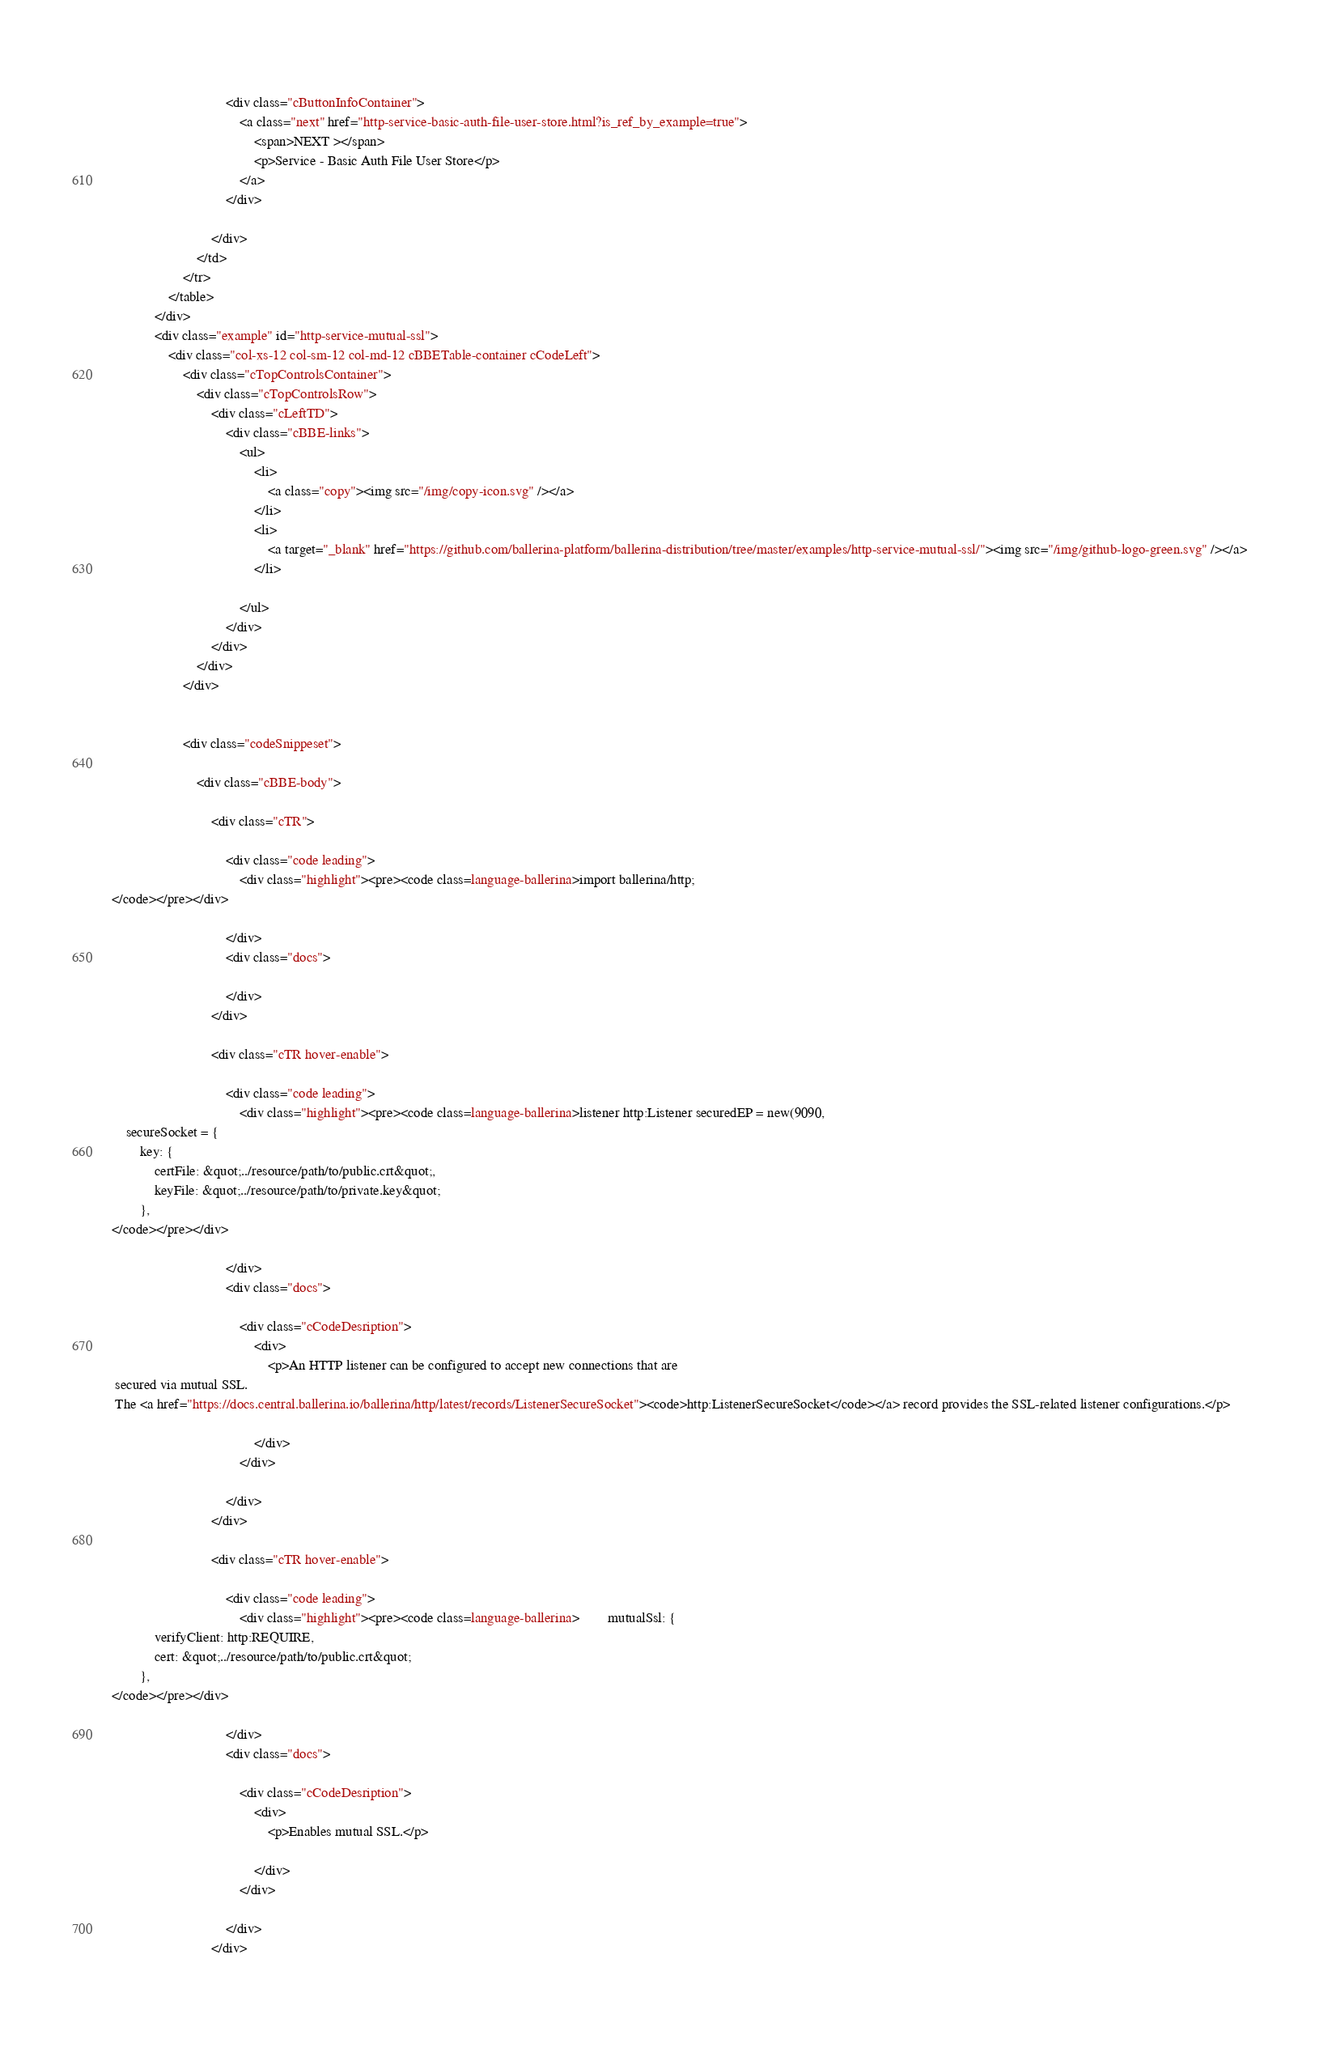Convert code to text. <code><loc_0><loc_0><loc_500><loc_500><_HTML_>                                 
                                <div class="cButtonInfoContainer">
                                    <a class="next" href="http-service-basic-auth-file-user-store.html?is_ref_by_example=true">
                                        <span>NEXT ></span>
                                        <p>Service - Basic Auth File User Store</p>
                                    </a>
                                </div>
                                
                            </div>
                        </td>
                    </tr>
                </table>
            </div>
            <div class="example" id="http-service-mutual-ssl">
                <div class="col-xs-12 col-sm-12 col-md-12 cBBETable-container cCodeLeft">
                    <div class="cTopControlsContainer">
                        <div class="cTopControlsRow">
                            <div class="cLeftTD">
                                <div class="cBBE-links">
                                    <ul>
                                        <li>
                                            <a class="copy"><img src="/img/copy-icon.svg" /></a>
                                        </li>
                                        <li>
                                            <a target="_blank" href="https://github.com/ballerina-platform/ballerina-distribution/tree/master/examples/http-service-mutual-ssl/"><img src="/img/github-logo-green.svg" /></a>
                                        </li>
                                        
                                    </ul>
                                </div>
                            </div> 
                        </div>
                    </div>
              
                    
                    <div class="codeSnippeset">

                        <div class="cBBE-body">
                            
                            <div class="cTR">

                                <div class="code leading">
                                    <div class="highlight"><pre><code class=language-ballerina>import ballerina/http;
</code></pre></div>

                                </div>
                                <div class="docs">
                                    
                                </div>
                            </div>
                            
                            <div class="cTR hover-enable">

                                <div class="code leading">
                                    <div class="highlight"><pre><code class=language-ballerina>listener http:Listener securedEP = new(9090,
    secureSocket = {
        key: {
            certFile: &quot;../resource/path/to/public.crt&quot;,
            keyFile: &quot;../resource/path/to/private.key&quot;
        },
</code></pre></div>

                                </div>
                                <div class="docs">
                                    
                                    <div class="cCodeDesription">
                                        <div>
                                            <p>An HTTP listener can be configured to accept new connections that are
 secured via mutual SSL.
 The <a href="https://docs.central.ballerina.io/ballerina/http/latest/records/ListenerSecureSocket"><code>http:ListenerSecureSocket</code></a> record provides the SSL-related listener configurations.</p>

                                        </div>
                                    </div>
                                    
                                </div>
                            </div>
                            
                            <div class="cTR hover-enable">

                                <div class="code leading">
                                    <div class="highlight"><pre><code class=language-ballerina>        mutualSsl: {
            verifyClient: http:REQUIRE,
            cert: &quot;../resource/path/to/public.crt&quot;
        },
</code></pre></div>

                                </div>
                                <div class="docs">
                                    
                                    <div class="cCodeDesription">
                                        <div>
                                            <p>Enables mutual SSL.</p>

                                        </div>
                                    </div>
                                    
                                </div>
                            </div>
                            </code> 